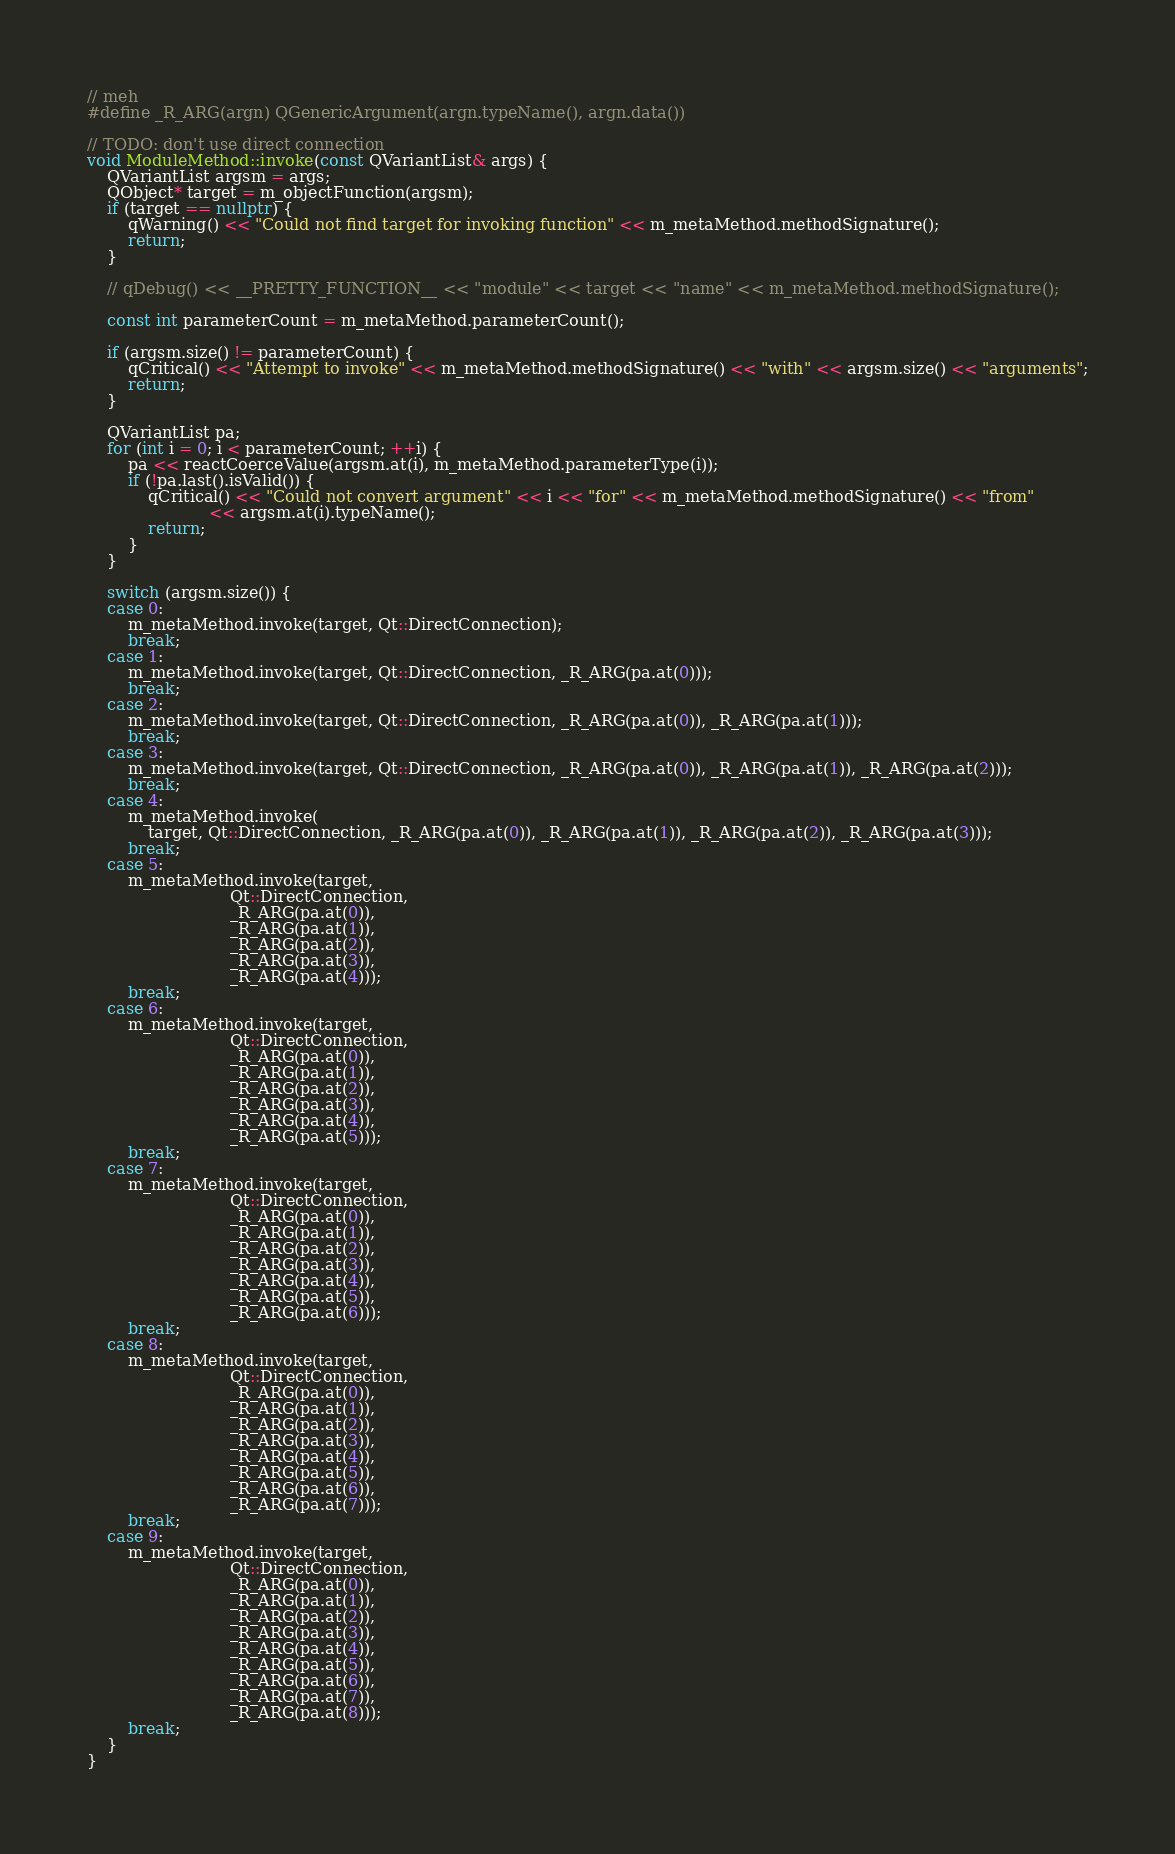<code> <loc_0><loc_0><loc_500><loc_500><_C++_>// meh
#define _R_ARG(argn) QGenericArgument(argn.typeName(), argn.data())

// TODO: don't use direct connection
void ModuleMethod::invoke(const QVariantList& args) {
    QVariantList argsm = args;
    QObject* target = m_objectFunction(argsm);
    if (target == nullptr) {
        qWarning() << "Could not find target for invoking function" << m_metaMethod.methodSignature();
        return;
    }

    // qDebug() << __PRETTY_FUNCTION__ << "module" << target << "name" << m_metaMethod.methodSignature();

    const int parameterCount = m_metaMethod.parameterCount();

    if (argsm.size() != parameterCount) {
        qCritical() << "Attempt to invoke" << m_metaMethod.methodSignature() << "with" << argsm.size() << "arguments";
        return;
    }

    QVariantList pa;
    for (int i = 0; i < parameterCount; ++i) {
        pa << reactCoerceValue(argsm.at(i), m_metaMethod.parameterType(i));
        if (!pa.last().isValid()) {
            qCritical() << "Could not convert argument" << i << "for" << m_metaMethod.methodSignature() << "from"
                        << argsm.at(i).typeName();
            return;
        }
    }

    switch (argsm.size()) {
    case 0:
        m_metaMethod.invoke(target, Qt::DirectConnection);
        break;
    case 1:
        m_metaMethod.invoke(target, Qt::DirectConnection, _R_ARG(pa.at(0)));
        break;
    case 2:
        m_metaMethod.invoke(target, Qt::DirectConnection, _R_ARG(pa.at(0)), _R_ARG(pa.at(1)));
        break;
    case 3:
        m_metaMethod.invoke(target, Qt::DirectConnection, _R_ARG(pa.at(0)), _R_ARG(pa.at(1)), _R_ARG(pa.at(2)));
        break;
    case 4:
        m_metaMethod.invoke(
            target, Qt::DirectConnection, _R_ARG(pa.at(0)), _R_ARG(pa.at(1)), _R_ARG(pa.at(2)), _R_ARG(pa.at(3)));
        break;
    case 5:
        m_metaMethod.invoke(target,
                            Qt::DirectConnection,
                            _R_ARG(pa.at(0)),
                            _R_ARG(pa.at(1)),
                            _R_ARG(pa.at(2)),
                            _R_ARG(pa.at(3)),
                            _R_ARG(pa.at(4)));
        break;
    case 6:
        m_metaMethod.invoke(target,
                            Qt::DirectConnection,
                            _R_ARG(pa.at(0)),
                            _R_ARG(pa.at(1)),
                            _R_ARG(pa.at(2)),
                            _R_ARG(pa.at(3)),
                            _R_ARG(pa.at(4)),
                            _R_ARG(pa.at(5)));
        break;
    case 7:
        m_metaMethod.invoke(target,
                            Qt::DirectConnection,
                            _R_ARG(pa.at(0)),
                            _R_ARG(pa.at(1)),
                            _R_ARG(pa.at(2)),
                            _R_ARG(pa.at(3)),
                            _R_ARG(pa.at(4)),
                            _R_ARG(pa.at(5)),
                            _R_ARG(pa.at(6)));
        break;
    case 8:
        m_metaMethod.invoke(target,
                            Qt::DirectConnection,
                            _R_ARG(pa.at(0)),
                            _R_ARG(pa.at(1)),
                            _R_ARG(pa.at(2)),
                            _R_ARG(pa.at(3)),
                            _R_ARG(pa.at(4)),
                            _R_ARG(pa.at(5)),
                            _R_ARG(pa.at(6)),
                            _R_ARG(pa.at(7)));
        break;
    case 9:
        m_metaMethod.invoke(target,
                            Qt::DirectConnection,
                            _R_ARG(pa.at(0)),
                            _R_ARG(pa.at(1)),
                            _R_ARG(pa.at(2)),
                            _R_ARG(pa.at(3)),
                            _R_ARG(pa.at(4)),
                            _R_ARG(pa.at(5)),
                            _R_ARG(pa.at(6)),
                            _R_ARG(pa.at(7)),
                            _R_ARG(pa.at(8)));
        break;
    }
}
</code> 